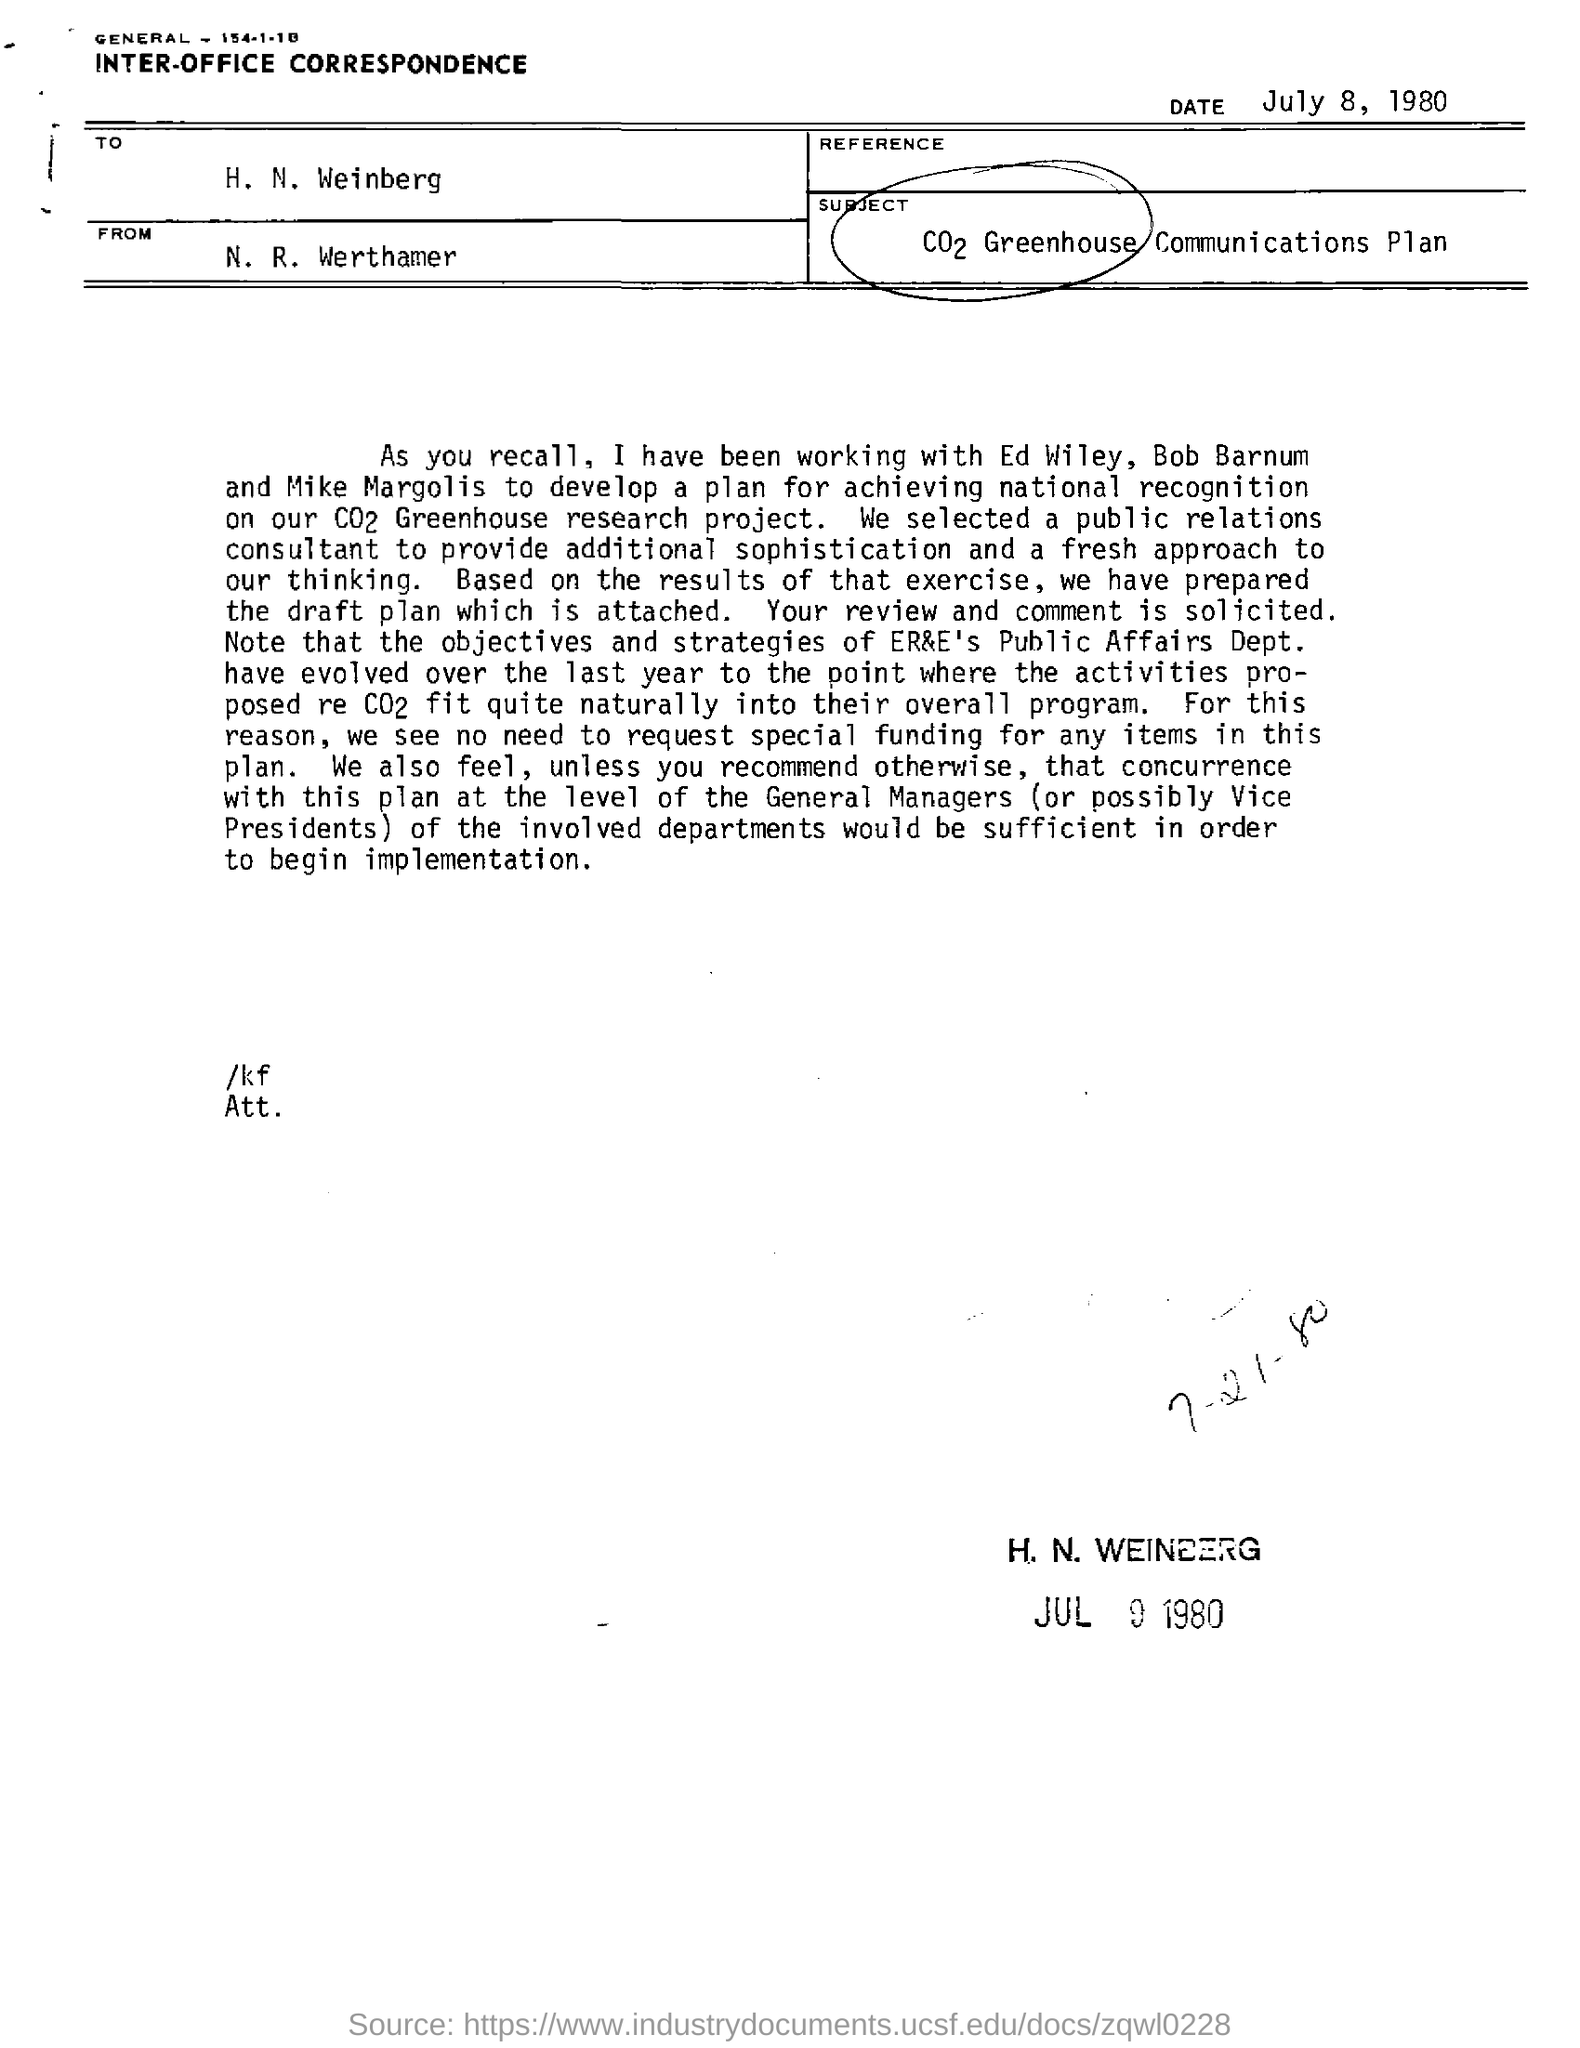When is the document dated?
Ensure brevity in your answer.  July 8, 1980. What type of documentation is this?
Provide a short and direct response. INTER-OFFICE CORRESPONDENCE. To whom is the document addressed?
Your answer should be compact. H. N. Weinberg. From whom is the document?
Keep it short and to the point. N. r. werthamer. 